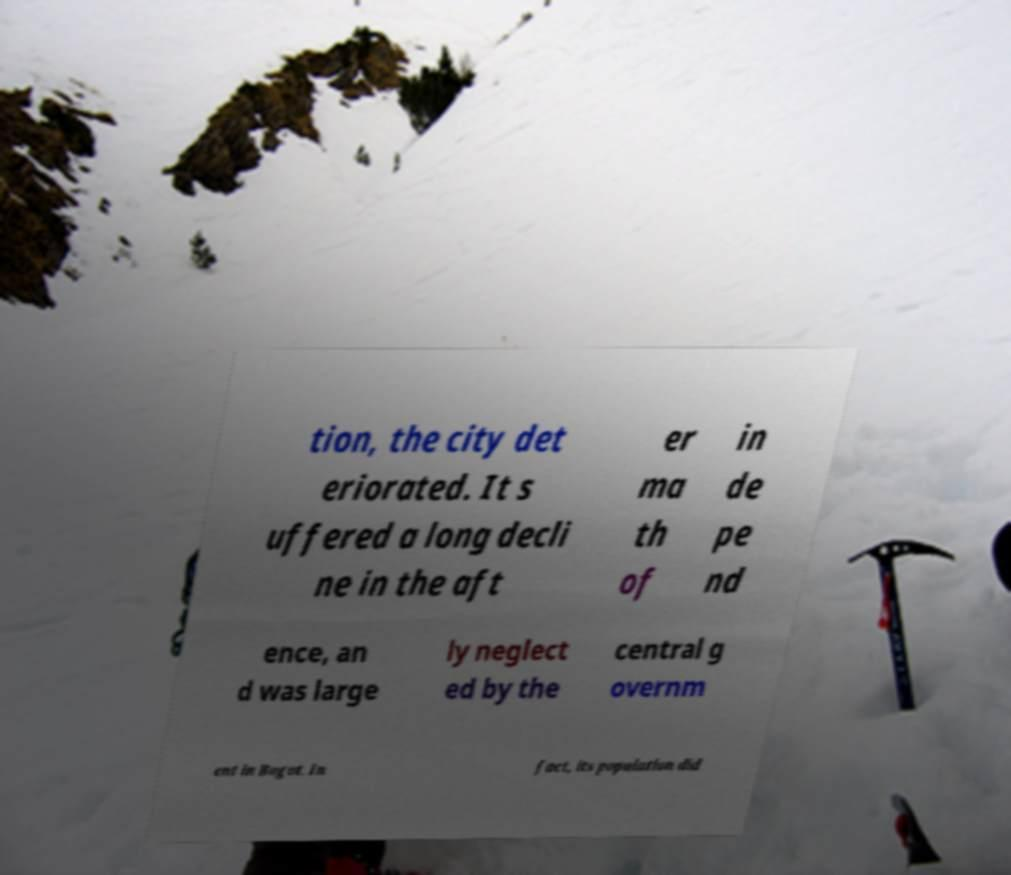Can you accurately transcribe the text from the provided image for me? tion, the city det eriorated. It s uffered a long decli ne in the aft er ma th of in de pe nd ence, an d was large ly neglect ed by the central g overnm ent in Bogot. In fact, its population did 